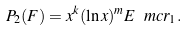Convert formula to latex. <formula><loc_0><loc_0><loc_500><loc_500>P _ { 2 } ( F ) = x ^ { k } ( \ln x ) ^ { m } E \ m c r _ { 1 } .</formula> 